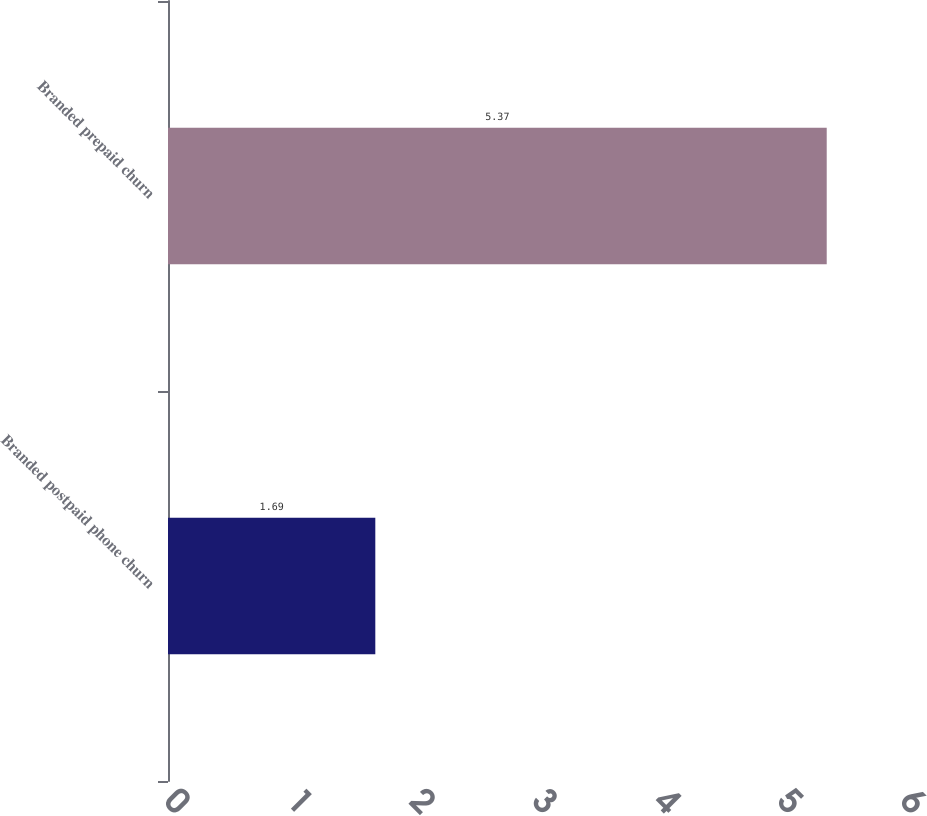<chart> <loc_0><loc_0><loc_500><loc_500><bar_chart><fcel>Branded postpaid phone churn<fcel>Branded prepaid churn<nl><fcel>1.69<fcel>5.37<nl></chart> 